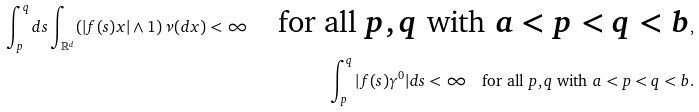Convert formula to latex. <formula><loc_0><loc_0><loc_500><loc_500>\int _ { p } ^ { q } d s \int _ { \mathbb { R } ^ { d } } ( | f ( s ) x | \land 1 ) \, \nu ( d x ) < \infty \quad \text {for all $p,q$ with $a<p<q<b$} , \\ \int _ { p } ^ { q } | f ( s ) \gamma ^ { 0 } | d s < \infty \quad \text {for all $p,q$ with $a<p<q<b$} .</formula> 